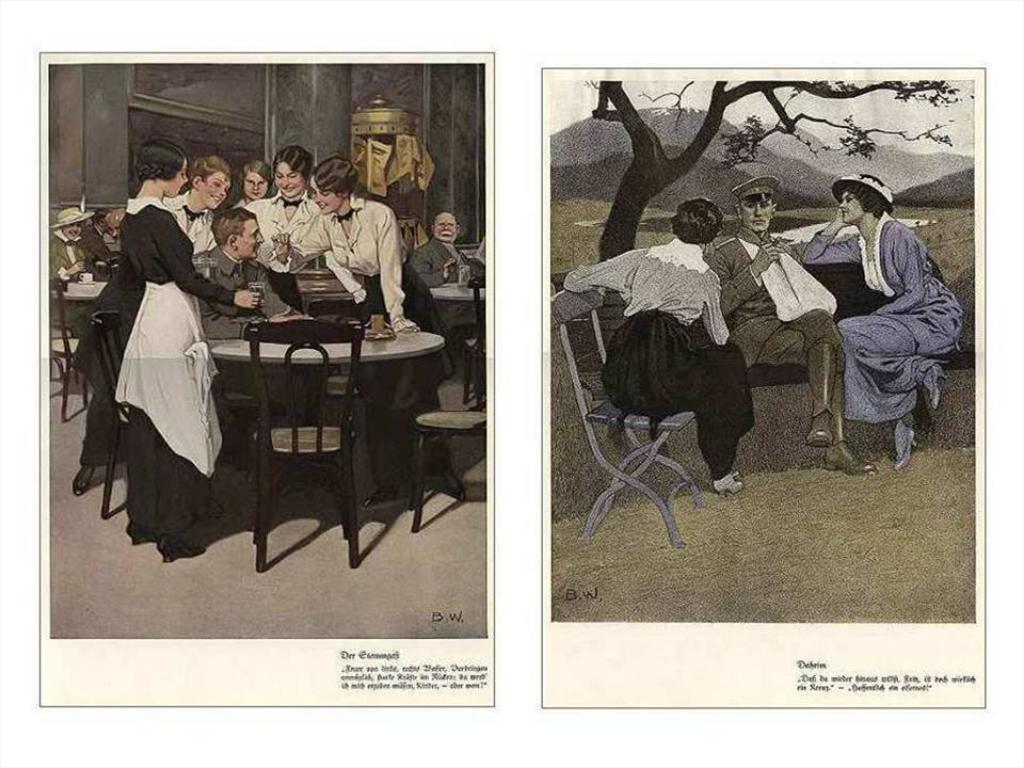In one or two sentences, can you explain what this image depicts? There are two images beside each one, on the left side image there is a man sitting in the front of dining table with girls surrounding around him, on the right side there is an officer sitting on bench under a tree with two girls beside him. 